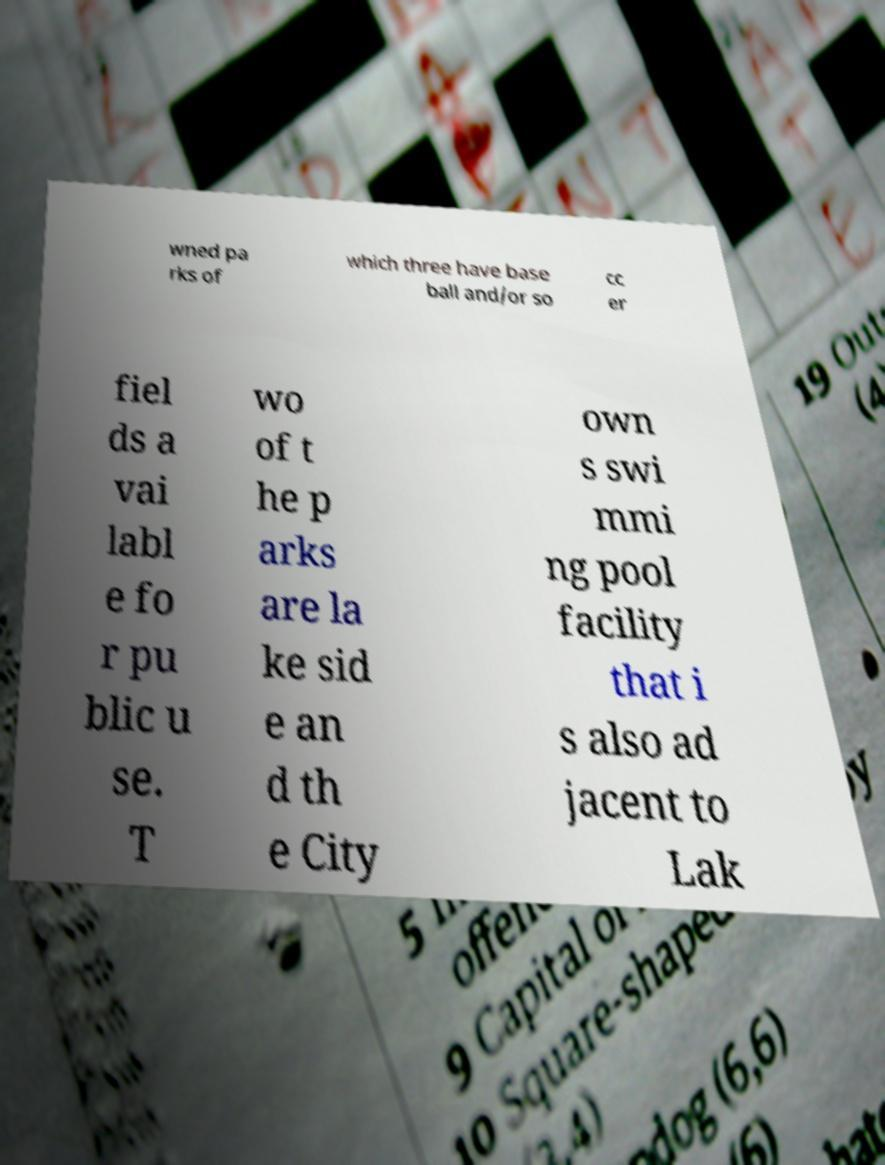For documentation purposes, I need the text within this image transcribed. Could you provide that? wned pa rks of which three have base ball and/or so cc er fiel ds a vai labl e fo r pu blic u se. T wo of t he p arks are la ke sid e an d th e City own s swi mmi ng pool facility that i s also ad jacent to Lak 